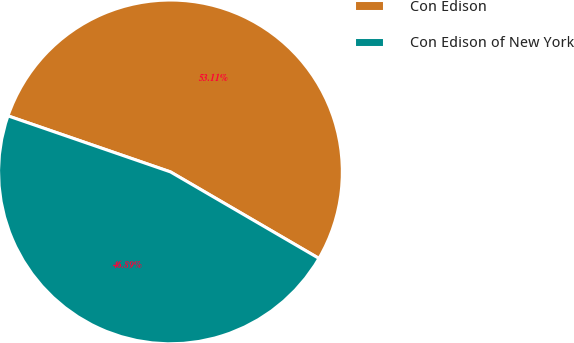Convert chart. <chart><loc_0><loc_0><loc_500><loc_500><pie_chart><fcel>Con Edison<fcel>Con Edison of New York<nl><fcel>53.11%<fcel>46.89%<nl></chart> 